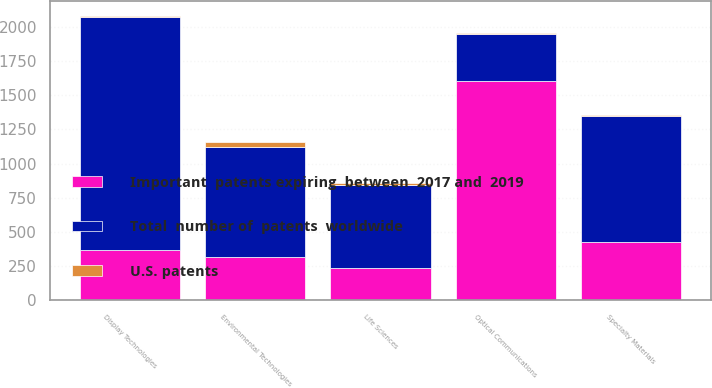Convert chart. <chart><loc_0><loc_0><loc_500><loc_500><stacked_bar_chart><ecel><fcel>Display Technologies<fcel>Optical Communications<fcel>Environmental Technologies<fcel>Specialty Materials<fcel>Life Sciences<nl><fcel>Total  number of  patents  worldwide<fcel>1700<fcel>345<fcel>800<fcel>920<fcel>600<nl><fcel>Important  patents expiring  between  2017 and  2019<fcel>370<fcel>1600<fcel>320<fcel>430<fcel>240<nl><fcel>U.S. patents<fcel>11<fcel>10<fcel>36<fcel>8<fcel>16<nl></chart> 